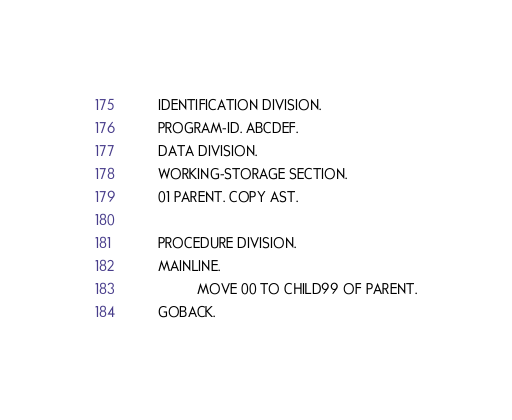Convert code to text. <code><loc_0><loc_0><loc_500><loc_500><_COBOL_>       IDENTIFICATION DIVISION.    
       PROGRAM-ID. ABCDEF.        
       DATA DIVISION.              
       WORKING-STORAGE SECTION.    
       01 PARENT. COPY AST.

       PROCEDURE DIVISION.
       MAINLINE.                   
                 MOVE 00 TO CHILD99 OF PARENT.
       GOBACK.
</code> 